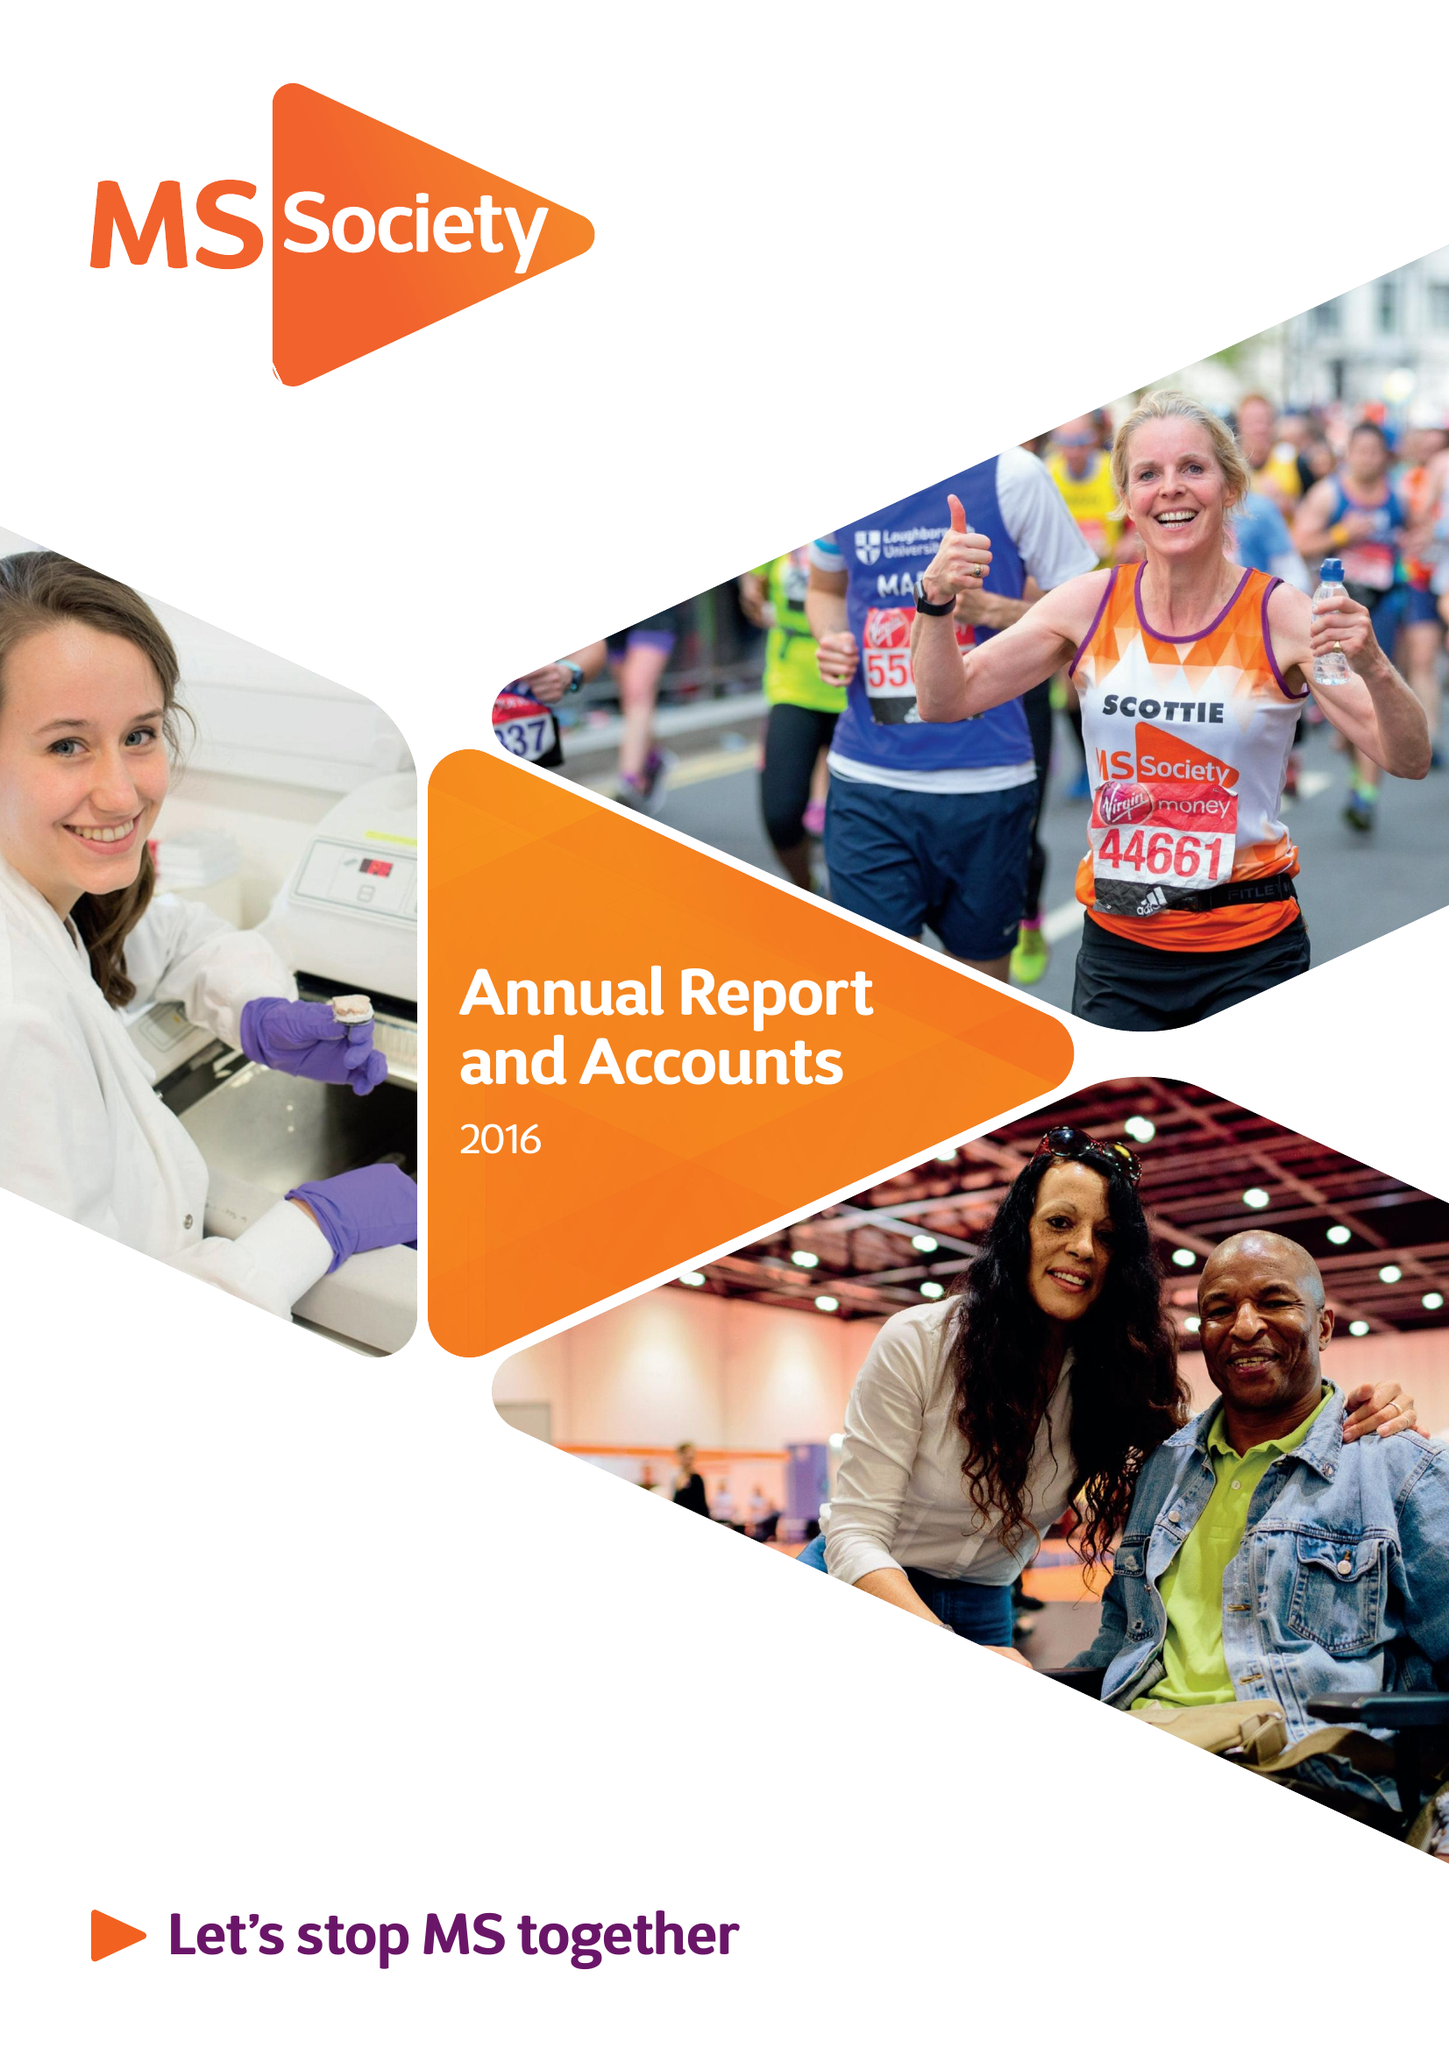What is the value for the spending_annually_in_british_pounds?
Answer the question using a single word or phrase. 29531000.00 